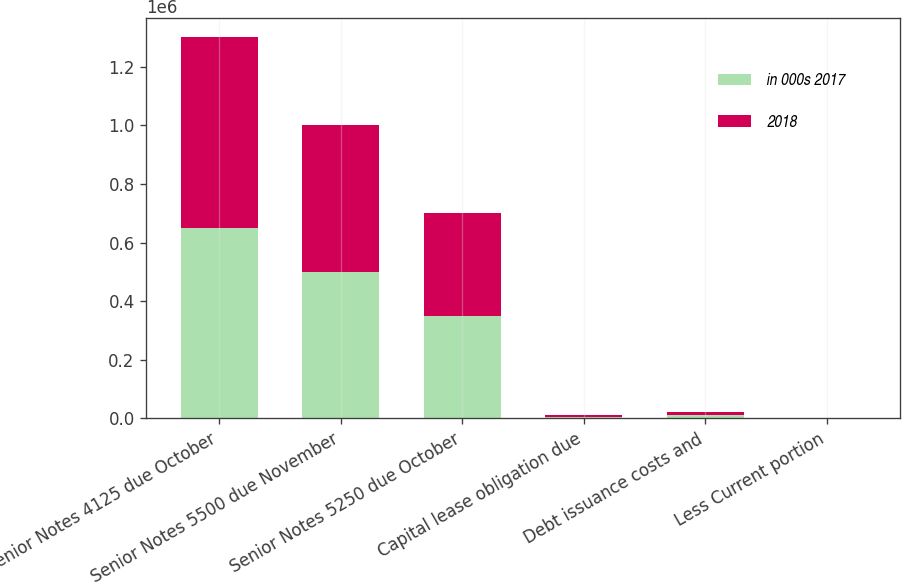<chart> <loc_0><loc_0><loc_500><loc_500><stacked_bar_chart><ecel><fcel>Senior Notes 4125 due October<fcel>Senior Notes 5500 due November<fcel>Senior Notes 5250 due October<fcel>Capital lease obligation due<fcel>Debt issuance costs and<fcel>Less Current portion<nl><fcel>in 000s 2017<fcel>650000<fcel>500000<fcel>350000<fcel>5628<fcel>9993<fcel>1026<nl><fcel>2018<fcel>650000<fcel>500000<fcel>350000<fcel>6610<fcel>12612<fcel>981<nl></chart> 